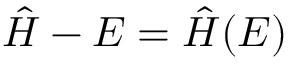Convert formula to latex. <formula><loc_0><loc_0><loc_500><loc_500>\hat { H } - E = \hat { H } ( E )</formula> 